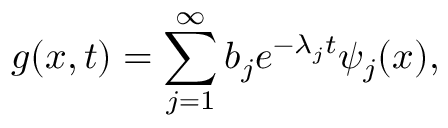<formula> <loc_0><loc_0><loc_500><loc_500>g ( x , t ) = \sum _ { j = 1 } ^ { \infty } b _ { j } e ^ { - \lambda _ { j } t } \psi _ { j } ( x ) ,</formula> 